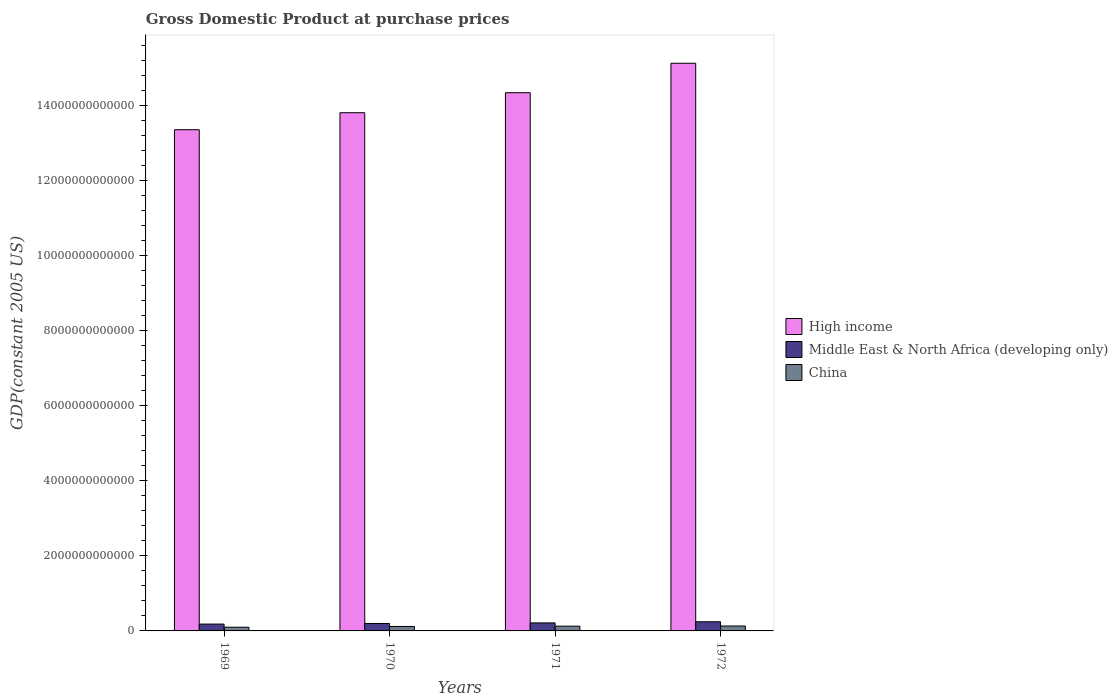How many different coloured bars are there?
Your answer should be compact. 3. How many groups of bars are there?
Your answer should be very brief. 4. How many bars are there on the 1st tick from the right?
Give a very brief answer. 3. What is the label of the 1st group of bars from the left?
Offer a very short reply. 1969. What is the GDP at purchase prices in High income in 1972?
Offer a very short reply. 1.51e+13. Across all years, what is the maximum GDP at purchase prices in High income?
Provide a short and direct response. 1.51e+13. Across all years, what is the minimum GDP at purchase prices in China?
Ensure brevity in your answer.  9.90e+1. In which year was the GDP at purchase prices in Middle East & North Africa (developing only) minimum?
Your response must be concise. 1969. What is the total GDP at purchase prices in China in the graph?
Provide a short and direct response. 4.75e+11. What is the difference between the GDP at purchase prices in Middle East & North Africa (developing only) in 1969 and that in 1971?
Keep it short and to the point. -3.06e+1. What is the difference between the GDP at purchase prices in Middle East & North Africa (developing only) in 1970 and the GDP at purchase prices in High income in 1972?
Offer a terse response. -1.49e+13. What is the average GDP at purchase prices in China per year?
Your answer should be compact. 1.19e+11. In the year 1971, what is the difference between the GDP at purchase prices in Middle East & North Africa (developing only) and GDP at purchase prices in China?
Provide a short and direct response. 8.66e+1. In how many years, is the GDP at purchase prices in Middle East & North Africa (developing only) greater than 12000000000000 US$?
Offer a terse response. 0. What is the ratio of the GDP at purchase prices in Middle East & North Africa (developing only) in 1969 to that in 1971?
Your response must be concise. 0.86. What is the difference between the highest and the second highest GDP at purchase prices in High income?
Your response must be concise. 7.84e+11. What is the difference between the highest and the lowest GDP at purchase prices in High income?
Give a very brief answer. 1.77e+12. In how many years, is the GDP at purchase prices in Middle East & North Africa (developing only) greater than the average GDP at purchase prices in Middle East & North Africa (developing only) taken over all years?
Provide a short and direct response. 2. What does the 1st bar from the right in 1972 represents?
Keep it short and to the point. China. What is the difference between two consecutive major ticks on the Y-axis?
Offer a very short reply. 2.00e+12. Does the graph contain grids?
Provide a short and direct response. No. How many legend labels are there?
Provide a succinct answer. 3. What is the title of the graph?
Ensure brevity in your answer.  Gross Domestic Product at purchase prices. What is the label or title of the Y-axis?
Your answer should be very brief. GDP(constant 2005 US). What is the GDP(constant 2005 US) in High income in 1969?
Your response must be concise. 1.33e+13. What is the GDP(constant 2005 US) of Middle East & North Africa (developing only) in 1969?
Offer a terse response. 1.83e+11. What is the GDP(constant 2005 US) in China in 1969?
Give a very brief answer. 9.90e+1. What is the GDP(constant 2005 US) of High income in 1970?
Provide a succinct answer. 1.38e+13. What is the GDP(constant 2005 US) of Middle East & North Africa (developing only) in 1970?
Your answer should be compact. 1.98e+11. What is the GDP(constant 2005 US) of China in 1970?
Your answer should be compact. 1.18e+11. What is the GDP(constant 2005 US) of High income in 1971?
Ensure brevity in your answer.  1.43e+13. What is the GDP(constant 2005 US) in Middle East & North Africa (developing only) in 1971?
Give a very brief answer. 2.13e+11. What is the GDP(constant 2005 US) in China in 1971?
Your answer should be very brief. 1.27e+11. What is the GDP(constant 2005 US) in High income in 1972?
Your answer should be very brief. 1.51e+13. What is the GDP(constant 2005 US) of Middle East & North Africa (developing only) in 1972?
Your answer should be very brief. 2.43e+11. What is the GDP(constant 2005 US) in China in 1972?
Provide a succinct answer. 1.31e+11. Across all years, what is the maximum GDP(constant 2005 US) of High income?
Offer a very short reply. 1.51e+13. Across all years, what is the maximum GDP(constant 2005 US) of Middle East & North Africa (developing only)?
Give a very brief answer. 2.43e+11. Across all years, what is the maximum GDP(constant 2005 US) of China?
Provide a short and direct response. 1.31e+11. Across all years, what is the minimum GDP(constant 2005 US) in High income?
Ensure brevity in your answer.  1.33e+13. Across all years, what is the minimum GDP(constant 2005 US) in Middle East & North Africa (developing only)?
Ensure brevity in your answer.  1.83e+11. Across all years, what is the minimum GDP(constant 2005 US) in China?
Keep it short and to the point. 9.90e+1. What is the total GDP(constant 2005 US) of High income in the graph?
Keep it short and to the point. 5.66e+13. What is the total GDP(constant 2005 US) of Middle East & North Africa (developing only) in the graph?
Provide a short and direct response. 8.38e+11. What is the total GDP(constant 2005 US) in China in the graph?
Give a very brief answer. 4.75e+11. What is the difference between the GDP(constant 2005 US) of High income in 1969 and that in 1970?
Keep it short and to the point. -4.52e+11. What is the difference between the GDP(constant 2005 US) in Middle East & North Africa (developing only) in 1969 and that in 1970?
Your answer should be compact. -1.58e+1. What is the difference between the GDP(constant 2005 US) of China in 1969 and that in 1970?
Keep it short and to the point. -1.92e+1. What is the difference between the GDP(constant 2005 US) in High income in 1969 and that in 1971?
Give a very brief answer. -9.85e+11. What is the difference between the GDP(constant 2005 US) of Middle East & North Africa (developing only) in 1969 and that in 1971?
Offer a very short reply. -3.06e+1. What is the difference between the GDP(constant 2005 US) of China in 1969 and that in 1971?
Your answer should be compact. -2.75e+1. What is the difference between the GDP(constant 2005 US) in High income in 1969 and that in 1972?
Your answer should be very brief. -1.77e+12. What is the difference between the GDP(constant 2005 US) of Middle East & North Africa (developing only) in 1969 and that in 1972?
Make the answer very short. -6.09e+1. What is the difference between the GDP(constant 2005 US) of China in 1969 and that in 1972?
Offer a very short reply. -3.23e+1. What is the difference between the GDP(constant 2005 US) of High income in 1970 and that in 1971?
Make the answer very short. -5.33e+11. What is the difference between the GDP(constant 2005 US) in Middle East & North Africa (developing only) in 1970 and that in 1971?
Ensure brevity in your answer.  -1.48e+1. What is the difference between the GDP(constant 2005 US) in China in 1970 and that in 1971?
Your answer should be very brief. -8.28e+09. What is the difference between the GDP(constant 2005 US) of High income in 1970 and that in 1972?
Provide a short and direct response. -1.32e+12. What is the difference between the GDP(constant 2005 US) of Middle East & North Africa (developing only) in 1970 and that in 1972?
Your response must be concise. -4.50e+1. What is the difference between the GDP(constant 2005 US) in China in 1970 and that in 1972?
Provide a succinct answer. -1.31e+1. What is the difference between the GDP(constant 2005 US) of High income in 1971 and that in 1972?
Provide a succinct answer. -7.84e+11. What is the difference between the GDP(constant 2005 US) in Middle East & North Africa (developing only) in 1971 and that in 1972?
Give a very brief answer. -3.03e+1. What is the difference between the GDP(constant 2005 US) in China in 1971 and that in 1972?
Offer a very short reply. -4.81e+09. What is the difference between the GDP(constant 2005 US) of High income in 1969 and the GDP(constant 2005 US) of Middle East & North Africa (developing only) in 1970?
Your response must be concise. 1.31e+13. What is the difference between the GDP(constant 2005 US) in High income in 1969 and the GDP(constant 2005 US) in China in 1970?
Keep it short and to the point. 1.32e+13. What is the difference between the GDP(constant 2005 US) in Middle East & North Africa (developing only) in 1969 and the GDP(constant 2005 US) in China in 1970?
Keep it short and to the point. 6.43e+1. What is the difference between the GDP(constant 2005 US) in High income in 1969 and the GDP(constant 2005 US) in Middle East & North Africa (developing only) in 1971?
Your answer should be very brief. 1.31e+13. What is the difference between the GDP(constant 2005 US) in High income in 1969 and the GDP(constant 2005 US) in China in 1971?
Make the answer very short. 1.32e+13. What is the difference between the GDP(constant 2005 US) in Middle East & North Africa (developing only) in 1969 and the GDP(constant 2005 US) in China in 1971?
Provide a succinct answer. 5.60e+1. What is the difference between the GDP(constant 2005 US) in High income in 1969 and the GDP(constant 2005 US) in Middle East & North Africa (developing only) in 1972?
Offer a very short reply. 1.31e+13. What is the difference between the GDP(constant 2005 US) of High income in 1969 and the GDP(constant 2005 US) of China in 1972?
Offer a very short reply. 1.32e+13. What is the difference between the GDP(constant 2005 US) of Middle East & North Africa (developing only) in 1969 and the GDP(constant 2005 US) of China in 1972?
Give a very brief answer. 5.12e+1. What is the difference between the GDP(constant 2005 US) in High income in 1970 and the GDP(constant 2005 US) in Middle East & North Africa (developing only) in 1971?
Your answer should be compact. 1.36e+13. What is the difference between the GDP(constant 2005 US) of High income in 1970 and the GDP(constant 2005 US) of China in 1971?
Keep it short and to the point. 1.37e+13. What is the difference between the GDP(constant 2005 US) of Middle East & North Africa (developing only) in 1970 and the GDP(constant 2005 US) of China in 1971?
Your answer should be very brief. 7.19e+1. What is the difference between the GDP(constant 2005 US) of High income in 1970 and the GDP(constant 2005 US) of Middle East & North Africa (developing only) in 1972?
Your response must be concise. 1.36e+13. What is the difference between the GDP(constant 2005 US) of High income in 1970 and the GDP(constant 2005 US) of China in 1972?
Provide a short and direct response. 1.37e+13. What is the difference between the GDP(constant 2005 US) in Middle East & North Africa (developing only) in 1970 and the GDP(constant 2005 US) in China in 1972?
Your answer should be compact. 6.71e+1. What is the difference between the GDP(constant 2005 US) in High income in 1971 and the GDP(constant 2005 US) in Middle East & North Africa (developing only) in 1972?
Provide a short and direct response. 1.41e+13. What is the difference between the GDP(constant 2005 US) in High income in 1971 and the GDP(constant 2005 US) in China in 1972?
Ensure brevity in your answer.  1.42e+13. What is the difference between the GDP(constant 2005 US) in Middle East & North Africa (developing only) in 1971 and the GDP(constant 2005 US) in China in 1972?
Ensure brevity in your answer.  8.18e+1. What is the average GDP(constant 2005 US) in High income per year?
Ensure brevity in your answer.  1.42e+13. What is the average GDP(constant 2005 US) of Middle East & North Africa (developing only) per year?
Ensure brevity in your answer.  2.09e+11. What is the average GDP(constant 2005 US) of China per year?
Offer a very short reply. 1.19e+11. In the year 1969, what is the difference between the GDP(constant 2005 US) in High income and GDP(constant 2005 US) in Middle East & North Africa (developing only)?
Provide a short and direct response. 1.32e+13. In the year 1969, what is the difference between the GDP(constant 2005 US) in High income and GDP(constant 2005 US) in China?
Ensure brevity in your answer.  1.32e+13. In the year 1969, what is the difference between the GDP(constant 2005 US) in Middle East & North Africa (developing only) and GDP(constant 2005 US) in China?
Ensure brevity in your answer.  8.35e+1. In the year 1970, what is the difference between the GDP(constant 2005 US) in High income and GDP(constant 2005 US) in Middle East & North Africa (developing only)?
Your response must be concise. 1.36e+13. In the year 1970, what is the difference between the GDP(constant 2005 US) of High income and GDP(constant 2005 US) of China?
Provide a succinct answer. 1.37e+13. In the year 1970, what is the difference between the GDP(constant 2005 US) of Middle East & North Africa (developing only) and GDP(constant 2005 US) of China?
Your answer should be very brief. 8.02e+1. In the year 1971, what is the difference between the GDP(constant 2005 US) in High income and GDP(constant 2005 US) in Middle East & North Africa (developing only)?
Your answer should be very brief. 1.41e+13. In the year 1971, what is the difference between the GDP(constant 2005 US) of High income and GDP(constant 2005 US) of China?
Your answer should be compact. 1.42e+13. In the year 1971, what is the difference between the GDP(constant 2005 US) in Middle East & North Africa (developing only) and GDP(constant 2005 US) in China?
Provide a succinct answer. 8.66e+1. In the year 1972, what is the difference between the GDP(constant 2005 US) in High income and GDP(constant 2005 US) in Middle East & North Africa (developing only)?
Offer a very short reply. 1.49e+13. In the year 1972, what is the difference between the GDP(constant 2005 US) of High income and GDP(constant 2005 US) of China?
Provide a succinct answer. 1.50e+13. In the year 1972, what is the difference between the GDP(constant 2005 US) of Middle East & North Africa (developing only) and GDP(constant 2005 US) of China?
Provide a short and direct response. 1.12e+11. What is the ratio of the GDP(constant 2005 US) of High income in 1969 to that in 1970?
Ensure brevity in your answer.  0.97. What is the ratio of the GDP(constant 2005 US) of Middle East & North Africa (developing only) in 1969 to that in 1970?
Make the answer very short. 0.92. What is the ratio of the GDP(constant 2005 US) of China in 1969 to that in 1970?
Provide a succinct answer. 0.84. What is the ratio of the GDP(constant 2005 US) in High income in 1969 to that in 1971?
Provide a succinct answer. 0.93. What is the ratio of the GDP(constant 2005 US) of Middle East & North Africa (developing only) in 1969 to that in 1971?
Give a very brief answer. 0.86. What is the ratio of the GDP(constant 2005 US) of China in 1969 to that in 1971?
Your response must be concise. 0.78. What is the ratio of the GDP(constant 2005 US) in High income in 1969 to that in 1972?
Your response must be concise. 0.88. What is the ratio of the GDP(constant 2005 US) in Middle East & North Africa (developing only) in 1969 to that in 1972?
Keep it short and to the point. 0.75. What is the ratio of the GDP(constant 2005 US) of China in 1969 to that in 1972?
Provide a short and direct response. 0.75. What is the ratio of the GDP(constant 2005 US) of High income in 1970 to that in 1971?
Make the answer very short. 0.96. What is the ratio of the GDP(constant 2005 US) in Middle East & North Africa (developing only) in 1970 to that in 1971?
Offer a very short reply. 0.93. What is the ratio of the GDP(constant 2005 US) of China in 1970 to that in 1971?
Offer a terse response. 0.93. What is the ratio of the GDP(constant 2005 US) in High income in 1970 to that in 1972?
Offer a very short reply. 0.91. What is the ratio of the GDP(constant 2005 US) in Middle East & North Africa (developing only) in 1970 to that in 1972?
Your response must be concise. 0.81. What is the ratio of the GDP(constant 2005 US) of China in 1970 to that in 1972?
Give a very brief answer. 0.9. What is the ratio of the GDP(constant 2005 US) in High income in 1971 to that in 1972?
Your answer should be compact. 0.95. What is the ratio of the GDP(constant 2005 US) of Middle East & North Africa (developing only) in 1971 to that in 1972?
Offer a terse response. 0.88. What is the ratio of the GDP(constant 2005 US) in China in 1971 to that in 1972?
Your answer should be very brief. 0.96. What is the difference between the highest and the second highest GDP(constant 2005 US) of High income?
Give a very brief answer. 7.84e+11. What is the difference between the highest and the second highest GDP(constant 2005 US) of Middle East & North Africa (developing only)?
Your response must be concise. 3.03e+1. What is the difference between the highest and the second highest GDP(constant 2005 US) of China?
Offer a very short reply. 4.81e+09. What is the difference between the highest and the lowest GDP(constant 2005 US) in High income?
Give a very brief answer. 1.77e+12. What is the difference between the highest and the lowest GDP(constant 2005 US) in Middle East & North Africa (developing only)?
Offer a terse response. 6.09e+1. What is the difference between the highest and the lowest GDP(constant 2005 US) of China?
Keep it short and to the point. 3.23e+1. 